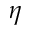Convert formula to latex. <formula><loc_0><loc_0><loc_500><loc_500>\eta</formula> 